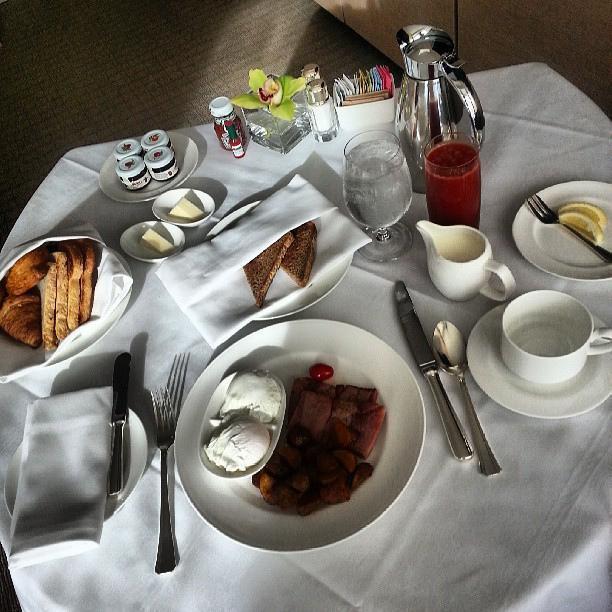When is the type of meal above favorable to be served?
Select the accurate response from the four choices given to answer the question.
Options: Afternoon, supper, breakfast, lunch. Breakfast. 